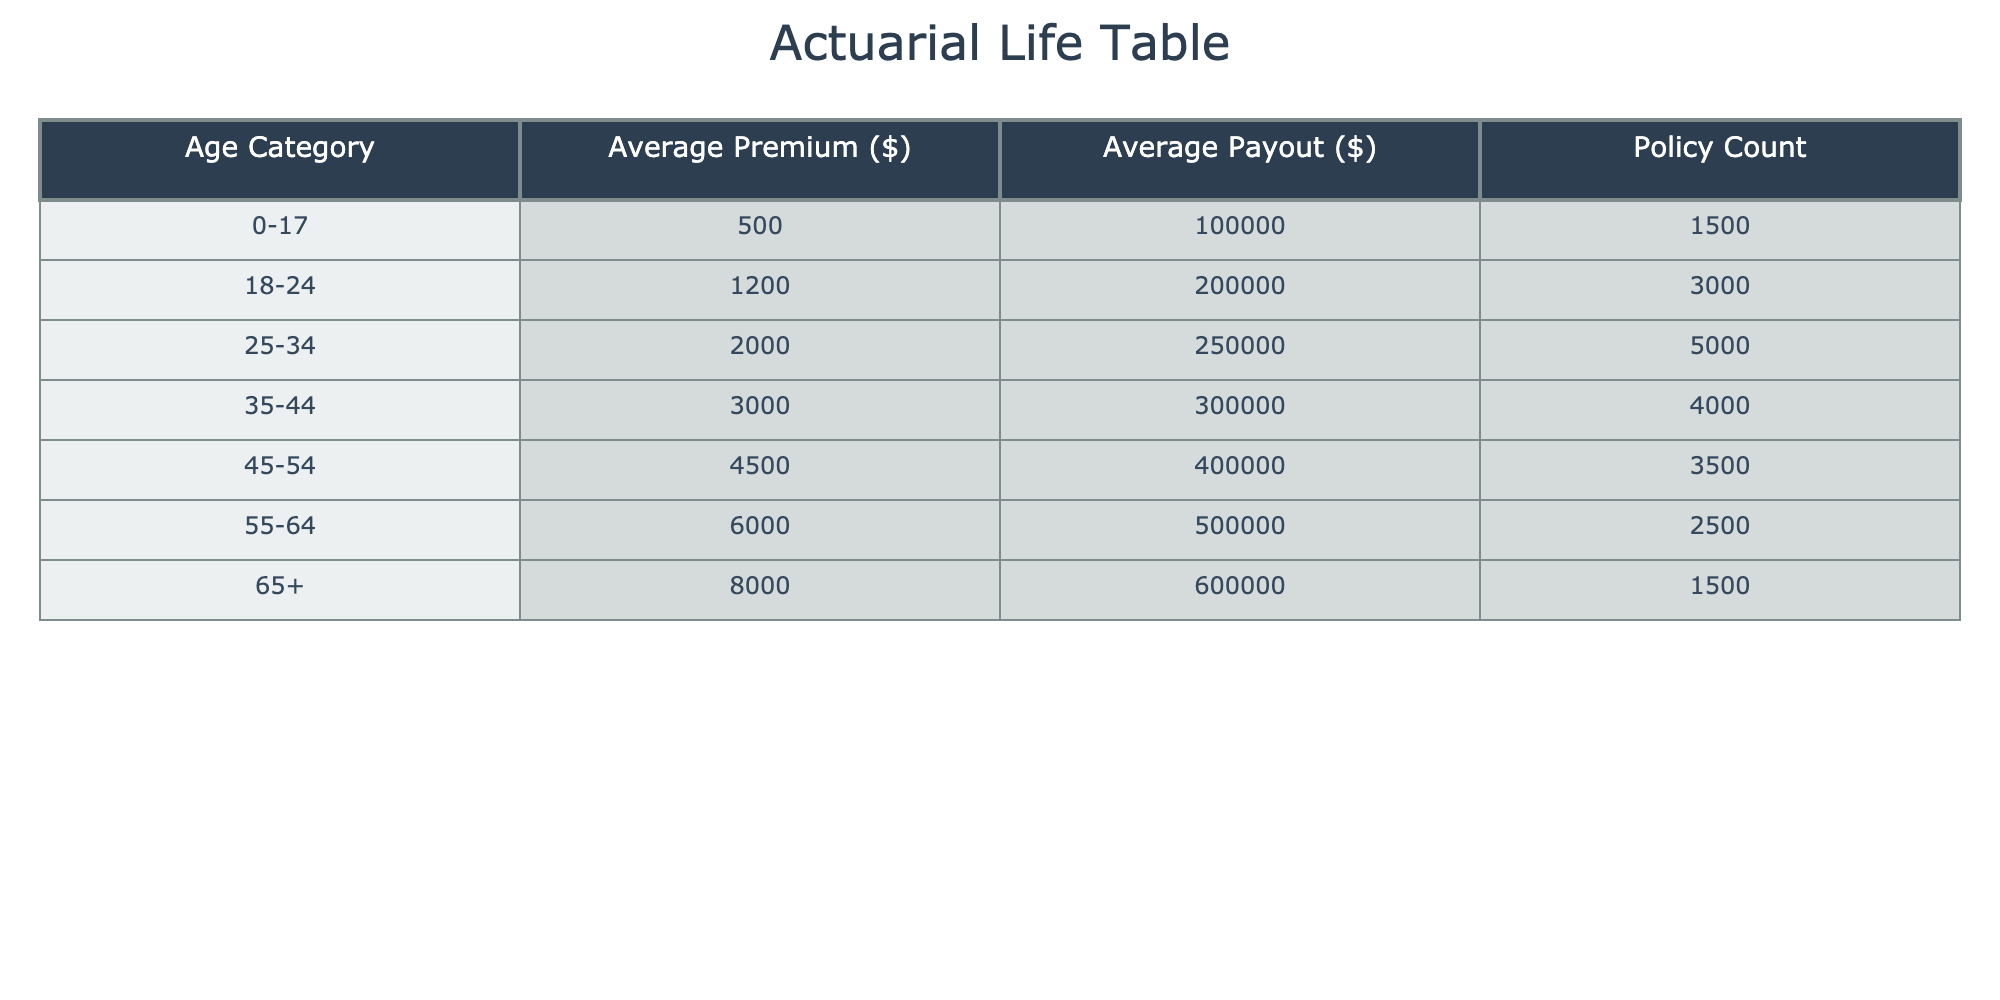What is the average premium for the age category 25-34? The average premium for the age category 25-34 is provided in the table under the "Average Premium ($)" column, which shows 2000.
Answer: 2000 What is the total policy count for all age categories combined? To find the total policy count, sum the values from the "Policy Count" column: 1500 + 3000 + 5000 + 4000 + 3500 + 2500 + 1500 = 20500.
Answer: 20500 Is the average payout for the age category 55-64 greater than 450000? The average payout for the age category 55-64 is listed as 500000 in the table, which is greater than 450000.
Answer: Yes What is the difference between the average premium for the age category 45-54 and the age category 35-44? The average premium for age category 45-54 is 4500 and for 35-44 is 3000. The difference is 4500 - 3000 = 1500.
Answer: 1500 How many age categories have an average premium greater than 4000? The table shows that only the age categories 55-64 (6000) and 65+ (8000) have an average premium greater than 4000. This totals to 2 age categories.
Answer: 2 What is the average payout for all categories combined? To compute the average payout, first multiply each age category's average payout by the respective policy count, sum those totals, and then divide by the total policy count. The calculation is: (100000*1500 + 200000*3000 + 250000*5000 + 300000*4000 + 400000*3500 + 500000*2500 + 600000*1500) / 20500, which results in an average of approximately 346.34.
Answer: 346.34 Is the average payout for the age category 18-24 less than 250000? Yes, the average payout for the age category 18-24 is 200000, which is less than 250000 according to the table.
Answer: Yes What is the combined average premium for the age categories 0-17 and 18-24? The average premium for age category 0-17 is 500, and for 18-24 is 1200. To find the combined average, add them together (500 + 1200) and divide by the number of categories (2): (500 + 1200) / 2 = 850.
Answer: 850 